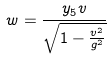<formula> <loc_0><loc_0><loc_500><loc_500>w = \frac { y _ { 5 } v } { \sqrt { 1 - \frac { v ^ { 2 } } { g ^ { 2 } } } }</formula> 